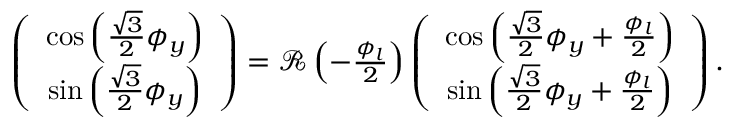<formula> <loc_0><loc_0><loc_500><loc_500>\begin{array} { r } { \left ( \begin{array} { c } { \cos \left ( \frac { \sqrt { 3 } } { 2 } \phi _ { y } \right ) } \\ { \sin \left ( \frac { \sqrt { 3 } } { 2 } \phi _ { y } \right ) } \end{array} \right ) = { \mathcal { R } } \left ( - \frac { \phi _ { l } } { 2 } \right ) \left ( \begin{array} { c } { \cos \left ( \frac { \sqrt { 3 } } { 2 } \phi _ { y } + \frac { \phi _ { l } } { 2 } \right ) } \\ { \sin \left ( \frac { \sqrt { 3 } } { 2 } \phi _ { y } + \frac { \phi _ { l } } { 2 } \right ) } \end{array} \right ) . } \end{array}</formula> 